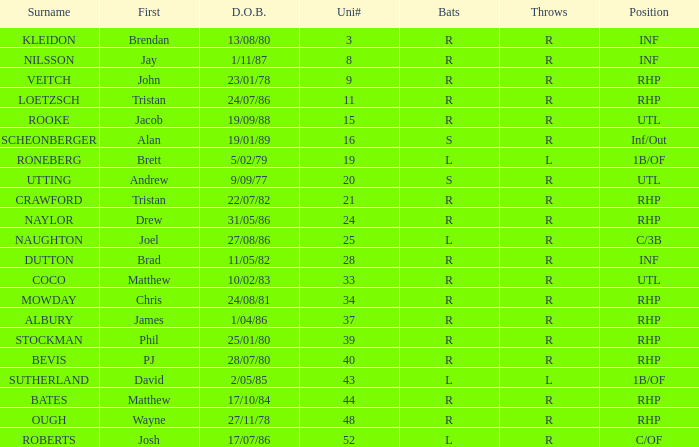Which First has a Uni # larger than 34, and Throws of r, and a Position of rhp, and a Surname of stockman? Phil. 